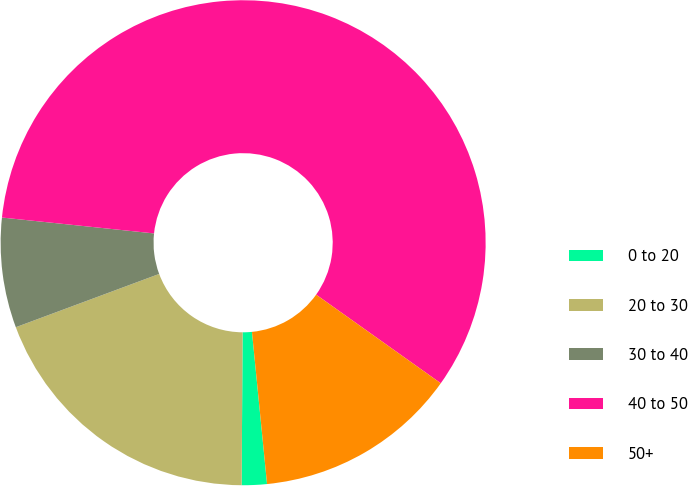<chart> <loc_0><loc_0><loc_500><loc_500><pie_chart><fcel>0 to 20<fcel>20 to 30<fcel>30 to 40<fcel>40 to 50<fcel>50+<nl><fcel>1.67%<fcel>19.24%<fcel>7.32%<fcel>58.18%<fcel>13.59%<nl></chart> 